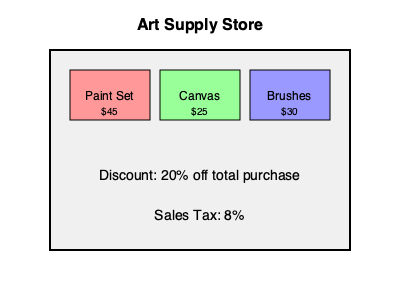As an independent artist, you're preparing for a new project and need to purchase supplies. Based on the information provided in the image, what would be the total cost of buying one of each item (paint set, canvas, and brushes) after applying the discount and including sales tax? To calculate the total cost, let's follow these steps:

1. Sum up the individual costs:
   Paint Set: $45
   Canvas: $25
   Brushes: $30
   Total before discount: $45 + $25 + $30 = $100

2. Apply the 20% discount:
   Discount amount: $100 × 0.20 = $20
   Price after discount: $100 - $20 = $80

3. Calculate the sales tax:
   Tax rate: 8%
   Tax amount: $80 × 0.08 = $6.40

4. Add the tax to the discounted price:
   Final total: $80 + $6.40 = $86.40

Therefore, the total cost after discount and including sales tax is $86.40.
Answer: $86.40 